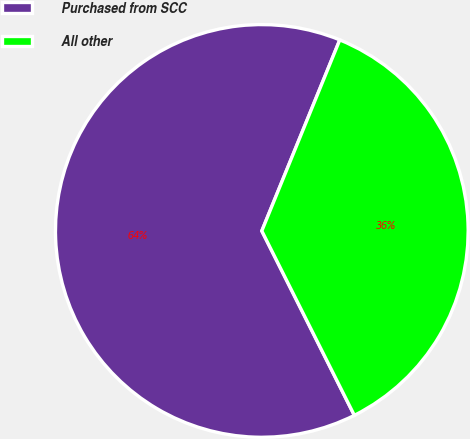Convert chart. <chart><loc_0><loc_0><loc_500><loc_500><pie_chart><fcel>Purchased from SCC<fcel>All other<nl><fcel>63.57%<fcel>36.43%<nl></chart> 